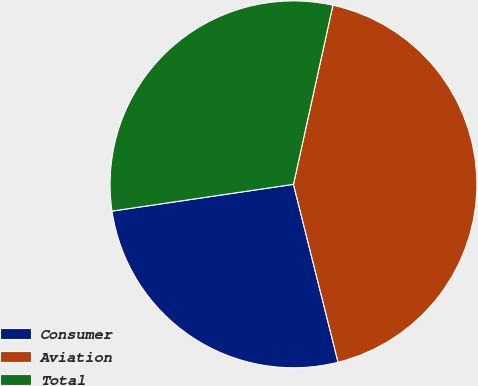Convert chart to OTSL. <chart><loc_0><loc_0><loc_500><loc_500><pie_chart><fcel>Consumer<fcel>Aviation<fcel>Total<nl><fcel>26.58%<fcel>42.64%<fcel>30.78%<nl></chart> 